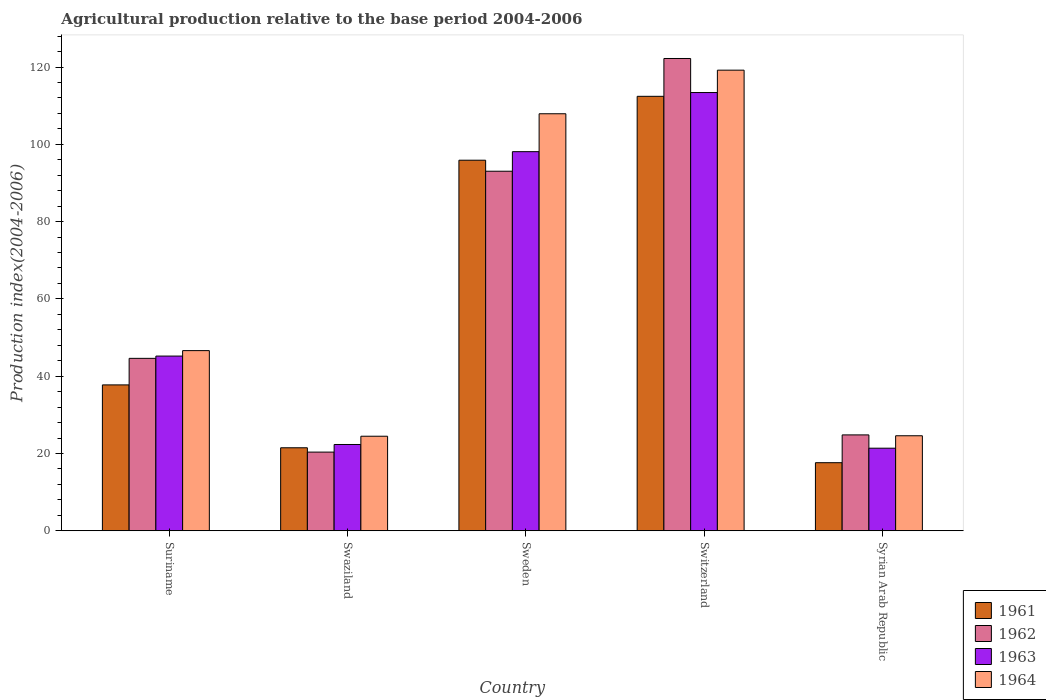How many different coloured bars are there?
Provide a short and direct response. 4. How many groups of bars are there?
Offer a terse response. 5. Are the number of bars on each tick of the X-axis equal?
Provide a short and direct response. Yes. In how many cases, is the number of bars for a given country not equal to the number of legend labels?
Your answer should be very brief. 0. What is the agricultural production index in 1964 in Suriname?
Offer a terse response. 46.62. Across all countries, what is the maximum agricultural production index in 1963?
Your response must be concise. 113.4. Across all countries, what is the minimum agricultural production index in 1964?
Your response must be concise. 24.47. In which country was the agricultural production index in 1961 maximum?
Ensure brevity in your answer.  Switzerland. In which country was the agricultural production index in 1962 minimum?
Give a very brief answer. Swaziland. What is the total agricultural production index in 1961 in the graph?
Provide a succinct answer. 285.16. What is the difference between the agricultural production index in 1964 in Suriname and that in Switzerland?
Ensure brevity in your answer.  -72.57. What is the difference between the agricultural production index in 1964 in Syrian Arab Republic and the agricultural production index in 1963 in Swaziland?
Make the answer very short. 2.26. What is the average agricultural production index in 1963 per country?
Ensure brevity in your answer.  60.08. What is the difference between the agricultural production index of/in 1961 and agricultural production index of/in 1963 in Suriname?
Your response must be concise. -7.46. In how many countries, is the agricultural production index in 1963 greater than 80?
Your answer should be compact. 2. What is the ratio of the agricultural production index in 1963 in Suriname to that in Swaziland?
Your response must be concise. 2.02. Is the difference between the agricultural production index in 1961 in Swaziland and Syrian Arab Republic greater than the difference between the agricultural production index in 1963 in Swaziland and Syrian Arab Republic?
Give a very brief answer. Yes. What is the difference between the highest and the second highest agricultural production index in 1964?
Your answer should be compact. 61.29. What is the difference between the highest and the lowest agricultural production index in 1963?
Keep it short and to the point. 92.03. Is the sum of the agricultural production index in 1964 in Switzerland and Syrian Arab Republic greater than the maximum agricultural production index in 1961 across all countries?
Offer a terse response. Yes. What does the 3rd bar from the left in Switzerland represents?
Your response must be concise. 1963. How many bars are there?
Provide a succinct answer. 20. How many countries are there in the graph?
Keep it short and to the point. 5. What is the difference between two consecutive major ticks on the Y-axis?
Make the answer very short. 20. Are the values on the major ticks of Y-axis written in scientific E-notation?
Ensure brevity in your answer.  No. Does the graph contain any zero values?
Provide a short and direct response. No. Does the graph contain grids?
Give a very brief answer. No. Where does the legend appear in the graph?
Offer a terse response. Bottom right. How are the legend labels stacked?
Ensure brevity in your answer.  Vertical. What is the title of the graph?
Offer a terse response. Agricultural production relative to the base period 2004-2006. Does "1987" appear as one of the legend labels in the graph?
Provide a succinct answer. No. What is the label or title of the X-axis?
Give a very brief answer. Country. What is the label or title of the Y-axis?
Provide a short and direct response. Production index(2004-2006). What is the Production index(2004-2006) of 1961 in Suriname?
Offer a very short reply. 37.75. What is the Production index(2004-2006) in 1962 in Suriname?
Ensure brevity in your answer.  44.62. What is the Production index(2004-2006) of 1963 in Suriname?
Provide a short and direct response. 45.21. What is the Production index(2004-2006) in 1964 in Suriname?
Your answer should be compact. 46.62. What is the Production index(2004-2006) in 1961 in Swaziland?
Offer a terse response. 21.48. What is the Production index(2004-2006) in 1962 in Swaziland?
Provide a short and direct response. 20.36. What is the Production index(2004-2006) of 1963 in Swaziland?
Provide a short and direct response. 22.33. What is the Production index(2004-2006) in 1964 in Swaziland?
Provide a succinct answer. 24.47. What is the Production index(2004-2006) in 1961 in Sweden?
Provide a short and direct response. 95.89. What is the Production index(2004-2006) in 1962 in Sweden?
Ensure brevity in your answer.  93.04. What is the Production index(2004-2006) of 1963 in Sweden?
Your response must be concise. 98.1. What is the Production index(2004-2006) in 1964 in Sweden?
Make the answer very short. 107.91. What is the Production index(2004-2006) in 1961 in Switzerland?
Ensure brevity in your answer.  112.42. What is the Production index(2004-2006) of 1962 in Switzerland?
Ensure brevity in your answer.  122.21. What is the Production index(2004-2006) of 1963 in Switzerland?
Provide a short and direct response. 113.4. What is the Production index(2004-2006) in 1964 in Switzerland?
Provide a succinct answer. 119.19. What is the Production index(2004-2006) of 1961 in Syrian Arab Republic?
Provide a short and direct response. 17.62. What is the Production index(2004-2006) of 1962 in Syrian Arab Republic?
Ensure brevity in your answer.  24.81. What is the Production index(2004-2006) of 1963 in Syrian Arab Republic?
Keep it short and to the point. 21.37. What is the Production index(2004-2006) in 1964 in Syrian Arab Republic?
Make the answer very short. 24.59. Across all countries, what is the maximum Production index(2004-2006) in 1961?
Offer a terse response. 112.42. Across all countries, what is the maximum Production index(2004-2006) of 1962?
Ensure brevity in your answer.  122.21. Across all countries, what is the maximum Production index(2004-2006) of 1963?
Your answer should be very brief. 113.4. Across all countries, what is the maximum Production index(2004-2006) of 1964?
Ensure brevity in your answer.  119.19. Across all countries, what is the minimum Production index(2004-2006) in 1961?
Your response must be concise. 17.62. Across all countries, what is the minimum Production index(2004-2006) of 1962?
Your response must be concise. 20.36. Across all countries, what is the minimum Production index(2004-2006) of 1963?
Provide a succinct answer. 21.37. Across all countries, what is the minimum Production index(2004-2006) of 1964?
Offer a terse response. 24.47. What is the total Production index(2004-2006) of 1961 in the graph?
Your response must be concise. 285.16. What is the total Production index(2004-2006) in 1962 in the graph?
Give a very brief answer. 305.04. What is the total Production index(2004-2006) of 1963 in the graph?
Offer a very short reply. 300.41. What is the total Production index(2004-2006) in 1964 in the graph?
Offer a terse response. 322.78. What is the difference between the Production index(2004-2006) in 1961 in Suriname and that in Swaziland?
Offer a terse response. 16.27. What is the difference between the Production index(2004-2006) in 1962 in Suriname and that in Swaziland?
Provide a short and direct response. 24.26. What is the difference between the Production index(2004-2006) of 1963 in Suriname and that in Swaziland?
Offer a very short reply. 22.88. What is the difference between the Production index(2004-2006) of 1964 in Suriname and that in Swaziland?
Your answer should be compact. 22.15. What is the difference between the Production index(2004-2006) of 1961 in Suriname and that in Sweden?
Your response must be concise. -58.14. What is the difference between the Production index(2004-2006) of 1962 in Suriname and that in Sweden?
Offer a very short reply. -48.42. What is the difference between the Production index(2004-2006) of 1963 in Suriname and that in Sweden?
Your answer should be compact. -52.89. What is the difference between the Production index(2004-2006) of 1964 in Suriname and that in Sweden?
Your answer should be compact. -61.29. What is the difference between the Production index(2004-2006) in 1961 in Suriname and that in Switzerland?
Provide a succinct answer. -74.67. What is the difference between the Production index(2004-2006) of 1962 in Suriname and that in Switzerland?
Offer a terse response. -77.59. What is the difference between the Production index(2004-2006) of 1963 in Suriname and that in Switzerland?
Make the answer very short. -68.19. What is the difference between the Production index(2004-2006) in 1964 in Suriname and that in Switzerland?
Ensure brevity in your answer.  -72.57. What is the difference between the Production index(2004-2006) of 1961 in Suriname and that in Syrian Arab Republic?
Your response must be concise. 20.13. What is the difference between the Production index(2004-2006) in 1962 in Suriname and that in Syrian Arab Republic?
Make the answer very short. 19.81. What is the difference between the Production index(2004-2006) of 1963 in Suriname and that in Syrian Arab Republic?
Your response must be concise. 23.84. What is the difference between the Production index(2004-2006) in 1964 in Suriname and that in Syrian Arab Republic?
Your answer should be compact. 22.03. What is the difference between the Production index(2004-2006) of 1961 in Swaziland and that in Sweden?
Give a very brief answer. -74.41. What is the difference between the Production index(2004-2006) of 1962 in Swaziland and that in Sweden?
Make the answer very short. -72.68. What is the difference between the Production index(2004-2006) of 1963 in Swaziland and that in Sweden?
Your answer should be compact. -75.77. What is the difference between the Production index(2004-2006) in 1964 in Swaziland and that in Sweden?
Provide a short and direct response. -83.44. What is the difference between the Production index(2004-2006) of 1961 in Swaziland and that in Switzerland?
Keep it short and to the point. -90.94. What is the difference between the Production index(2004-2006) of 1962 in Swaziland and that in Switzerland?
Give a very brief answer. -101.85. What is the difference between the Production index(2004-2006) of 1963 in Swaziland and that in Switzerland?
Your answer should be very brief. -91.07. What is the difference between the Production index(2004-2006) in 1964 in Swaziland and that in Switzerland?
Keep it short and to the point. -94.72. What is the difference between the Production index(2004-2006) of 1961 in Swaziland and that in Syrian Arab Republic?
Make the answer very short. 3.86. What is the difference between the Production index(2004-2006) in 1962 in Swaziland and that in Syrian Arab Republic?
Your answer should be very brief. -4.45. What is the difference between the Production index(2004-2006) of 1963 in Swaziland and that in Syrian Arab Republic?
Offer a very short reply. 0.96. What is the difference between the Production index(2004-2006) in 1964 in Swaziland and that in Syrian Arab Republic?
Offer a very short reply. -0.12. What is the difference between the Production index(2004-2006) of 1961 in Sweden and that in Switzerland?
Provide a succinct answer. -16.53. What is the difference between the Production index(2004-2006) of 1962 in Sweden and that in Switzerland?
Your answer should be very brief. -29.17. What is the difference between the Production index(2004-2006) in 1963 in Sweden and that in Switzerland?
Keep it short and to the point. -15.3. What is the difference between the Production index(2004-2006) of 1964 in Sweden and that in Switzerland?
Your response must be concise. -11.28. What is the difference between the Production index(2004-2006) of 1961 in Sweden and that in Syrian Arab Republic?
Your response must be concise. 78.27. What is the difference between the Production index(2004-2006) of 1962 in Sweden and that in Syrian Arab Republic?
Provide a succinct answer. 68.23. What is the difference between the Production index(2004-2006) of 1963 in Sweden and that in Syrian Arab Republic?
Ensure brevity in your answer.  76.73. What is the difference between the Production index(2004-2006) in 1964 in Sweden and that in Syrian Arab Republic?
Provide a short and direct response. 83.32. What is the difference between the Production index(2004-2006) of 1961 in Switzerland and that in Syrian Arab Republic?
Your answer should be compact. 94.8. What is the difference between the Production index(2004-2006) of 1962 in Switzerland and that in Syrian Arab Republic?
Make the answer very short. 97.4. What is the difference between the Production index(2004-2006) in 1963 in Switzerland and that in Syrian Arab Republic?
Provide a succinct answer. 92.03. What is the difference between the Production index(2004-2006) of 1964 in Switzerland and that in Syrian Arab Republic?
Your response must be concise. 94.6. What is the difference between the Production index(2004-2006) in 1961 in Suriname and the Production index(2004-2006) in 1962 in Swaziland?
Give a very brief answer. 17.39. What is the difference between the Production index(2004-2006) in 1961 in Suriname and the Production index(2004-2006) in 1963 in Swaziland?
Your answer should be compact. 15.42. What is the difference between the Production index(2004-2006) in 1961 in Suriname and the Production index(2004-2006) in 1964 in Swaziland?
Provide a short and direct response. 13.28. What is the difference between the Production index(2004-2006) of 1962 in Suriname and the Production index(2004-2006) of 1963 in Swaziland?
Your response must be concise. 22.29. What is the difference between the Production index(2004-2006) of 1962 in Suriname and the Production index(2004-2006) of 1964 in Swaziland?
Offer a very short reply. 20.15. What is the difference between the Production index(2004-2006) of 1963 in Suriname and the Production index(2004-2006) of 1964 in Swaziland?
Offer a terse response. 20.74. What is the difference between the Production index(2004-2006) of 1961 in Suriname and the Production index(2004-2006) of 1962 in Sweden?
Give a very brief answer. -55.29. What is the difference between the Production index(2004-2006) of 1961 in Suriname and the Production index(2004-2006) of 1963 in Sweden?
Make the answer very short. -60.35. What is the difference between the Production index(2004-2006) of 1961 in Suriname and the Production index(2004-2006) of 1964 in Sweden?
Offer a very short reply. -70.16. What is the difference between the Production index(2004-2006) of 1962 in Suriname and the Production index(2004-2006) of 1963 in Sweden?
Give a very brief answer. -53.48. What is the difference between the Production index(2004-2006) of 1962 in Suriname and the Production index(2004-2006) of 1964 in Sweden?
Give a very brief answer. -63.29. What is the difference between the Production index(2004-2006) in 1963 in Suriname and the Production index(2004-2006) in 1964 in Sweden?
Offer a terse response. -62.7. What is the difference between the Production index(2004-2006) in 1961 in Suriname and the Production index(2004-2006) in 1962 in Switzerland?
Provide a succinct answer. -84.46. What is the difference between the Production index(2004-2006) in 1961 in Suriname and the Production index(2004-2006) in 1963 in Switzerland?
Provide a short and direct response. -75.65. What is the difference between the Production index(2004-2006) in 1961 in Suriname and the Production index(2004-2006) in 1964 in Switzerland?
Offer a very short reply. -81.44. What is the difference between the Production index(2004-2006) of 1962 in Suriname and the Production index(2004-2006) of 1963 in Switzerland?
Keep it short and to the point. -68.78. What is the difference between the Production index(2004-2006) of 1962 in Suriname and the Production index(2004-2006) of 1964 in Switzerland?
Provide a short and direct response. -74.57. What is the difference between the Production index(2004-2006) in 1963 in Suriname and the Production index(2004-2006) in 1964 in Switzerland?
Make the answer very short. -73.98. What is the difference between the Production index(2004-2006) in 1961 in Suriname and the Production index(2004-2006) in 1962 in Syrian Arab Republic?
Your response must be concise. 12.94. What is the difference between the Production index(2004-2006) in 1961 in Suriname and the Production index(2004-2006) in 1963 in Syrian Arab Republic?
Keep it short and to the point. 16.38. What is the difference between the Production index(2004-2006) in 1961 in Suriname and the Production index(2004-2006) in 1964 in Syrian Arab Republic?
Your answer should be compact. 13.16. What is the difference between the Production index(2004-2006) in 1962 in Suriname and the Production index(2004-2006) in 1963 in Syrian Arab Republic?
Ensure brevity in your answer.  23.25. What is the difference between the Production index(2004-2006) of 1962 in Suriname and the Production index(2004-2006) of 1964 in Syrian Arab Republic?
Give a very brief answer. 20.03. What is the difference between the Production index(2004-2006) in 1963 in Suriname and the Production index(2004-2006) in 1964 in Syrian Arab Republic?
Make the answer very short. 20.62. What is the difference between the Production index(2004-2006) in 1961 in Swaziland and the Production index(2004-2006) in 1962 in Sweden?
Make the answer very short. -71.56. What is the difference between the Production index(2004-2006) of 1961 in Swaziland and the Production index(2004-2006) of 1963 in Sweden?
Give a very brief answer. -76.62. What is the difference between the Production index(2004-2006) in 1961 in Swaziland and the Production index(2004-2006) in 1964 in Sweden?
Make the answer very short. -86.43. What is the difference between the Production index(2004-2006) in 1962 in Swaziland and the Production index(2004-2006) in 1963 in Sweden?
Your answer should be compact. -77.74. What is the difference between the Production index(2004-2006) of 1962 in Swaziland and the Production index(2004-2006) of 1964 in Sweden?
Make the answer very short. -87.55. What is the difference between the Production index(2004-2006) in 1963 in Swaziland and the Production index(2004-2006) in 1964 in Sweden?
Provide a succinct answer. -85.58. What is the difference between the Production index(2004-2006) of 1961 in Swaziland and the Production index(2004-2006) of 1962 in Switzerland?
Offer a very short reply. -100.73. What is the difference between the Production index(2004-2006) in 1961 in Swaziland and the Production index(2004-2006) in 1963 in Switzerland?
Give a very brief answer. -91.92. What is the difference between the Production index(2004-2006) of 1961 in Swaziland and the Production index(2004-2006) of 1964 in Switzerland?
Your answer should be very brief. -97.71. What is the difference between the Production index(2004-2006) of 1962 in Swaziland and the Production index(2004-2006) of 1963 in Switzerland?
Your answer should be very brief. -93.04. What is the difference between the Production index(2004-2006) in 1962 in Swaziland and the Production index(2004-2006) in 1964 in Switzerland?
Offer a very short reply. -98.83. What is the difference between the Production index(2004-2006) in 1963 in Swaziland and the Production index(2004-2006) in 1964 in Switzerland?
Your answer should be very brief. -96.86. What is the difference between the Production index(2004-2006) in 1961 in Swaziland and the Production index(2004-2006) in 1962 in Syrian Arab Republic?
Your answer should be very brief. -3.33. What is the difference between the Production index(2004-2006) of 1961 in Swaziland and the Production index(2004-2006) of 1963 in Syrian Arab Republic?
Keep it short and to the point. 0.11. What is the difference between the Production index(2004-2006) of 1961 in Swaziland and the Production index(2004-2006) of 1964 in Syrian Arab Republic?
Provide a succinct answer. -3.11. What is the difference between the Production index(2004-2006) in 1962 in Swaziland and the Production index(2004-2006) in 1963 in Syrian Arab Republic?
Offer a terse response. -1.01. What is the difference between the Production index(2004-2006) in 1962 in Swaziland and the Production index(2004-2006) in 1964 in Syrian Arab Republic?
Give a very brief answer. -4.23. What is the difference between the Production index(2004-2006) of 1963 in Swaziland and the Production index(2004-2006) of 1964 in Syrian Arab Republic?
Provide a succinct answer. -2.26. What is the difference between the Production index(2004-2006) of 1961 in Sweden and the Production index(2004-2006) of 1962 in Switzerland?
Provide a succinct answer. -26.32. What is the difference between the Production index(2004-2006) of 1961 in Sweden and the Production index(2004-2006) of 1963 in Switzerland?
Your answer should be very brief. -17.51. What is the difference between the Production index(2004-2006) of 1961 in Sweden and the Production index(2004-2006) of 1964 in Switzerland?
Your answer should be very brief. -23.3. What is the difference between the Production index(2004-2006) in 1962 in Sweden and the Production index(2004-2006) in 1963 in Switzerland?
Offer a very short reply. -20.36. What is the difference between the Production index(2004-2006) in 1962 in Sweden and the Production index(2004-2006) in 1964 in Switzerland?
Keep it short and to the point. -26.15. What is the difference between the Production index(2004-2006) of 1963 in Sweden and the Production index(2004-2006) of 1964 in Switzerland?
Make the answer very short. -21.09. What is the difference between the Production index(2004-2006) of 1961 in Sweden and the Production index(2004-2006) of 1962 in Syrian Arab Republic?
Offer a terse response. 71.08. What is the difference between the Production index(2004-2006) of 1961 in Sweden and the Production index(2004-2006) of 1963 in Syrian Arab Republic?
Ensure brevity in your answer.  74.52. What is the difference between the Production index(2004-2006) in 1961 in Sweden and the Production index(2004-2006) in 1964 in Syrian Arab Republic?
Provide a succinct answer. 71.3. What is the difference between the Production index(2004-2006) in 1962 in Sweden and the Production index(2004-2006) in 1963 in Syrian Arab Republic?
Offer a terse response. 71.67. What is the difference between the Production index(2004-2006) of 1962 in Sweden and the Production index(2004-2006) of 1964 in Syrian Arab Republic?
Provide a short and direct response. 68.45. What is the difference between the Production index(2004-2006) in 1963 in Sweden and the Production index(2004-2006) in 1964 in Syrian Arab Republic?
Keep it short and to the point. 73.51. What is the difference between the Production index(2004-2006) of 1961 in Switzerland and the Production index(2004-2006) of 1962 in Syrian Arab Republic?
Make the answer very short. 87.61. What is the difference between the Production index(2004-2006) of 1961 in Switzerland and the Production index(2004-2006) of 1963 in Syrian Arab Republic?
Your answer should be compact. 91.05. What is the difference between the Production index(2004-2006) in 1961 in Switzerland and the Production index(2004-2006) in 1964 in Syrian Arab Republic?
Ensure brevity in your answer.  87.83. What is the difference between the Production index(2004-2006) in 1962 in Switzerland and the Production index(2004-2006) in 1963 in Syrian Arab Republic?
Make the answer very short. 100.84. What is the difference between the Production index(2004-2006) of 1962 in Switzerland and the Production index(2004-2006) of 1964 in Syrian Arab Republic?
Offer a terse response. 97.62. What is the difference between the Production index(2004-2006) in 1963 in Switzerland and the Production index(2004-2006) in 1964 in Syrian Arab Republic?
Keep it short and to the point. 88.81. What is the average Production index(2004-2006) of 1961 per country?
Make the answer very short. 57.03. What is the average Production index(2004-2006) of 1962 per country?
Your answer should be very brief. 61.01. What is the average Production index(2004-2006) of 1963 per country?
Offer a very short reply. 60.08. What is the average Production index(2004-2006) in 1964 per country?
Offer a terse response. 64.56. What is the difference between the Production index(2004-2006) of 1961 and Production index(2004-2006) of 1962 in Suriname?
Your response must be concise. -6.87. What is the difference between the Production index(2004-2006) in 1961 and Production index(2004-2006) in 1963 in Suriname?
Offer a terse response. -7.46. What is the difference between the Production index(2004-2006) in 1961 and Production index(2004-2006) in 1964 in Suriname?
Your answer should be very brief. -8.87. What is the difference between the Production index(2004-2006) of 1962 and Production index(2004-2006) of 1963 in Suriname?
Provide a short and direct response. -0.59. What is the difference between the Production index(2004-2006) of 1963 and Production index(2004-2006) of 1964 in Suriname?
Ensure brevity in your answer.  -1.41. What is the difference between the Production index(2004-2006) in 1961 and Production index(2004-2006) in 1962 in Swaziland?
Your answer should be very brief. 1.12. What is the difference between the Production index(2004-2006) in 1961 and Production index(2004-2006) in 1963 in Swaziland?
Give a very brief answer. -0.85. What is the difference between the Production index(2004-2006) in 1961 and Production index(2004-2006) in 1964 in Swaziland?
Provide a short and direct response. -2.99. What is the difference between the Production index(2004-2006) in 1962 and Production index(2004-2006) in 1963 in Swaziland?
Your answer should be compact. -1.97. What is the difference between the Production index(2004-2006) in 1962 and Production index(2004-2006) in 1964 in Swaziland?
Give a very brief answer. -4.11. What is the difference between the Production index(2004-2006) in 1963 and Production index(2004-2006) in 1964 in Swaziland?
Provide a short and direct response. -2.14. What is the difference between the Production index(2004-2006) of 1961 and Production index(2004-2006) of 1962 in Sweden?
Your response must be concise. 2.85. What is the difference between the Production index(2004-2006) of 1961 and Production index(2004-2006) of 1963 in Sweden?
Ensure brevity in your answer.  -2.21. What is the difference between the Production index(2004-2006) in 1961 and Production index(2004-2006) in 1964 in Sweden?
Provide a short and direct response. -12.02. What is the difference between the Production index(2004-2006) in 1962 and Production index(2004-2006) in 1963 in Sweden?
Provide a short and direct response. -5.06. What is the difference between the Production index(2004-2006) of 1962 and Production index(2004-2006) of 1964 in Sweden?
Give a very brief answer. -14.87. What is the difference between the Production index(2004-2006) in 1963 and Production index(2004-2006) in 1964 in Sweden?
Ensure brevity in your answer.  -9.81. What is the difference between the Production index(2004-2006) in 1961 and Production index(2004-2006) in 1962 in Switzerland?
Your answer should be compact. -9.79. What is the difference between the Production index(2004-2006) of 1961 and Production index(2004-2006) of 1963 in Switzerland?
Ensure brevity in your answer.  -0.98. What is the difference between the Production index(2004-2006) of 1961 and Production index(2004-2006) of 1964 in Switzerland?
Keep it short and to the point. -6.77. What is the difference between the Production index(2004-2006) of 1962 and Production index(2004-2006) of 1963 in Switzerland?
Provide a succinct answer. 8.81. What is the difference between the Production index(2004-2006) in 1962 and Production index(2004-2006) in 1964 in Switzerland?
Your response must be concise. 3.02. What is the difference between the Production index(2004-2006) in 1963 and Production index(2004-2006) in 1964 in Switzerland?
Provide a succinct answer. -5.79. What is the difference between the Production index(2004-2006) in 1961 and Production index(2004-2006) in 1962 in Syrian Arab Republic?
Make the answer very short. -7.19. What is the difference between the Production index(2004-2006) of 1961 and Production index(2004-2006) of 1963 in Syrian Arab Republic?
Offer a very short reply. -3.75. What is the difference between the Production index(2004-2006) of 1961 and Production index(2004-2006) of 1964 in Syrian Arab Republic?
Your answer should be very brief. -6.97. What is the difference between the Production index(2004-2006) in 1962 and Production index(2004-2006) in 1963 in Syrian Arab Republic?
Provide a short and direct response. 3.44. What is the difference between the Production index(2004-2006) in 1962 and Production index(2004-2006) in 1964 in Syrian Arab Republic?
Provide a succinct answer. 0.22. What is the difference between the Production index(2004-2006) in 1963 and Production index(2004-2006) in 1964 in Syrian Arab Republic?
Give a very brief answer. -3.22. What is the ratio of the Production index(2004-2006) in 1961 in Suriname to that in Swaziland?
Your answer should be very brief. 1.76. What is the ratio of the Production index(2004-2006) in 1962 in Suriname to that in Swaziland?
Make the answer very short. 2.19. What is the ratio of the Production index(2004-2006) in 1963 in Suriname to that in Swaziland?
Provide a succinct answer. 2.02. What is the ratio of the Production index(2004-2006) of 1964 in Suriname to that in Swaziland?
Ensure brevity in your answer.  1.91. What is the ratio of the Production index(2004-2006) of 1961 in Suriname to that in Sweden?
Offer a very short reply. 0.39. What is the ratio of the Production index(2004-2006) of 1962 in Suriname to that in Sweden?
Your answer should be very brief. 0.48. What is the ratio of the Production index(2004-2006) of 1963 in Suriname to that in Sweden?
Your answer should be very brief. 0.46. What is the ratio of the Production index(2004-2006) in 1964 in Suriname to that in Sweden?
Ensure brevity in your answer.  0.43. What is the ratio of the Production index(2004-2006) of 1961 in Suriname to that in Switzerland?
Give a very brief answer. 0.34. What is the ratio of the Production index(2004-2006) in 1962 in Suriname to that in Switzerland?
Offer a very short reply. 0.37. What is the ratio of the Production index(2004-2006) in 1963 in Suriname to that in Switzerland?
Your answer should be compact. 0.4. What is the ratio of the Production index(2004-2006) of 1964 in Suriname to that in Switzerland?
Ensure brevity in your answer.  0.39. What is the ratio of the Production index(2004-2006) of 1961 in Suriname to that in Syrian Arab Republic?
Provide a short and direct response. 2.14. What is the ratio of the Production index(2004-2006) in 1962 in Suriname to that in Syrian Arab Republic?
Offer a very short reply. 1.8. What is the ratio of the Production index(2004-2006) in 1963 in Suriname to that in Syrian Arab Republic?
Offer a very short reply. 2.12. What is the ratio of the Production index(2004-2006) in 1964 in Suriname to that in Syrian Arab Republic?
Offer a very short reply. 1.9. What is the ratio of the Production index(2004-2006) of 1961 in Swaziland to that in Sweden?
Give a very brief answer. 0.22. What is the ratio of the Production index(2004-2006) of 1962 in Swaziland to that in Sweden?
Give a very brief answer. 0.22. What is the ratio of the Production index(2004-2006) in 1963 in Swaziland to that in Sweden?
Make the answer very short. 0.23. What is the ratio of the Production index(2004-2006) in 1964 in Swaziland to that in Sweden?
Offer a terse response. 0.23. What is the ratio of the Production index(2004-2006) of 1961 in Swaziland to that in Switzerland?
Your answer should be compact. 0.19. What is the ratio of the Production index(2004-2006) of 1962 in Swaziland to that in Switzerland?
Your answer should be compact. 0.17. What is the ratio of the Production index(2004-2006) of 1963 in Swaziland to that in Switzerland?
Your answer should be very brief. 0.2. What is the ratio of the Production index(2004-2006) of 1964 in Swaziland to that in Switzerland?
Make the answer very short. 0.21. What is the ratio of the Production index(2004-2006) in 1961 in Swaziland to that in Syrian Arab Republic?
Offer a very short reply. 1.22. What is the ratio of the Production index(2004-2006) of 1962 in Swaziland to that in Syrian Arab Republic?
Offer a very short reply. 0.82. What is the ratio of the Production index(2004-2006) in 1963 in Swaziland to that in Syrian Arab Republic?
Your answer should be compact. 1.04. What is the ratio of the Production index(2004-2006) in 1964 in Swaziland to that in Syrian Arab Republic?
Give a very brief answer. 1. What is the ratio of the Production index(2004-2006) in 1961 in Sweden to that in Switzerland?
Provide a short and direct response. 0.85. What is the ratio of the Production index(2004-2006) of 1962 in Sweden to that in Switzerland?
Offer a terse response. 0.76. What is the ratio of the Production index(2004-2006) of 1963 in Sweden to that in Switzerland?
Provide a succinct answer. 0.87. What is the ratio of the Production index(2004-2006) in 1964 in Sweden to that in Switzerland?
Ensure brevity in your answer.  0.91. What is the ratio of the Production index(2004-2006) of 1961 in Sweden to that in Syrian Arab Republic?
Provide a short and direct response. 5.44. What is the ratio of the Production index(2004-2006) of 1962 in Sweden to that in Syrian Arab Republic?
Your answer should be compact. 3.75. What is the ratio of the Production index(2004-2006) of 1963 in Sweden to that in Syrian Arab Republic?
Offer a terse response. 4.59. What is the ratio of the Production index(2004-2006) of 1964 in Sweden to that in Syrian Arab Republic?
Provide a short and direct response. 4.39. What is the ratio of the Production index(2004-2006) in 1961 in Switzerland to that in Syrian Arab Republic?
Offer a very short reply. 6.38. What is the ratio of the Production index(2004-2006) of 1962 in Switzerland to that in Syrian Arab Republic?
Make the answer very short. 4.93. What is the ratio of the Production index(2004-2006) of 1963 in Switzerland to that in Syrian Arab Republic?
Offer a terse response. 5.31. What is the ratio of the Production index(2004-2006) of 1964 in Switzerland to that in Syrian Arab Republic?
Provide a short and direct response. 4.85. What is the difference between the highest and the second highest Production index(2004-2006) in 1961?
Offer a very short reply. 16.53. What is the difference between the highest and the second highest Production index(2004-2006) in 1962?
Provide a succinct answer. 29.17. What is the difference between the highest and the second highest Production index(2004-2006) in 1964?
Provide a short and direct response. 11.28. What is the difference between the highest and the lowest Production index(2004-2006) in 1961?
Make the answer very short. 94.8. What is the difference between the highest and the lowest Production index(2004-2006) in 1962?
Keep it short and to the point. 101.85. What is the difference between the highest and the lowest Production index(2004-2006) in 1963?
Offer a very short reply. 92.03. What is the difference between the highest and the lowest Production index(2004-2006) of 1964?
Provide a short and direct response. 94.72. 